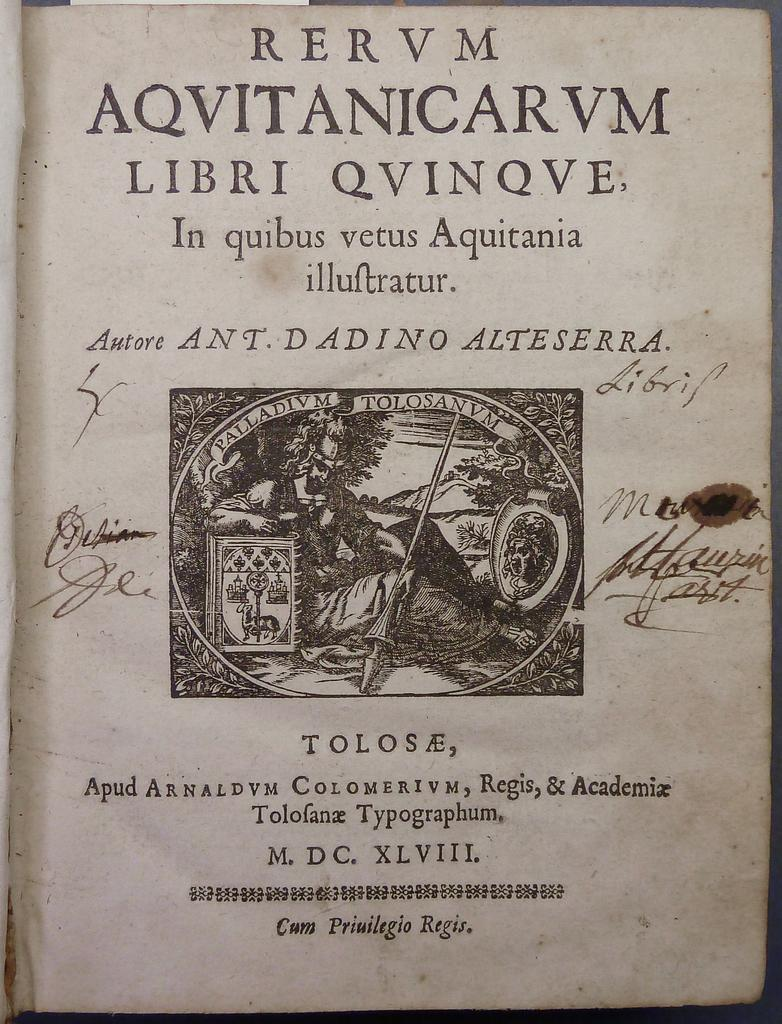<image>
Relay a brief, clear account of the picture shown. Aqvitanicarvm libri qvinqve chapter book with roman numerals 